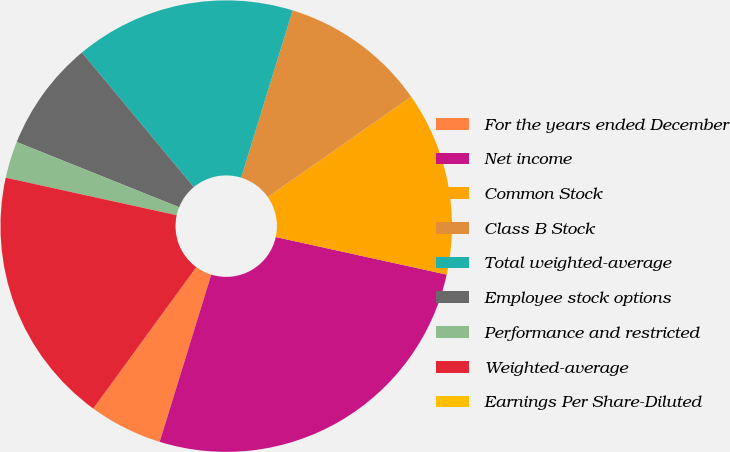Convert chart. <chart><loc_0><loc_0><loc_500><loc_500><pie_chart><fcel>For the years ended December<fcel>Net income<fcel>Common Stock<fcel>Class B Stock<fcel>Total weighted-average<fcel>Employee stock options<fcel>Performance and restricted<fcel>Weighted-average<fcel>Earnings Per Share-Diluted<nl><fcel>5.26%<fcel>26.32%<fcel>13.16%<fcel>10.53%<fcel>15.79%<fcel>7.89%<fcel>2.63%<fcel>18.42%<fcel>0.0%<nl></chart> 